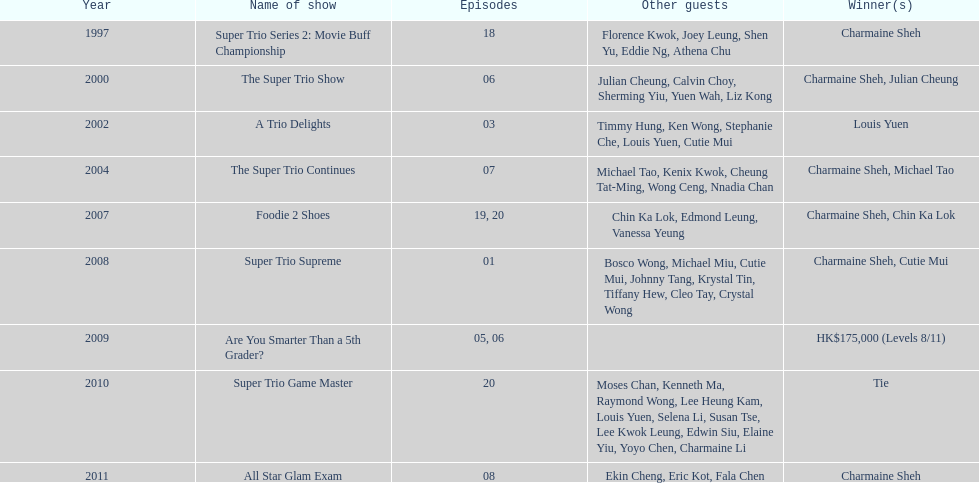In how many back-to-back trio shows did charmaine sheh take part before switching to a different variety program? 34. 